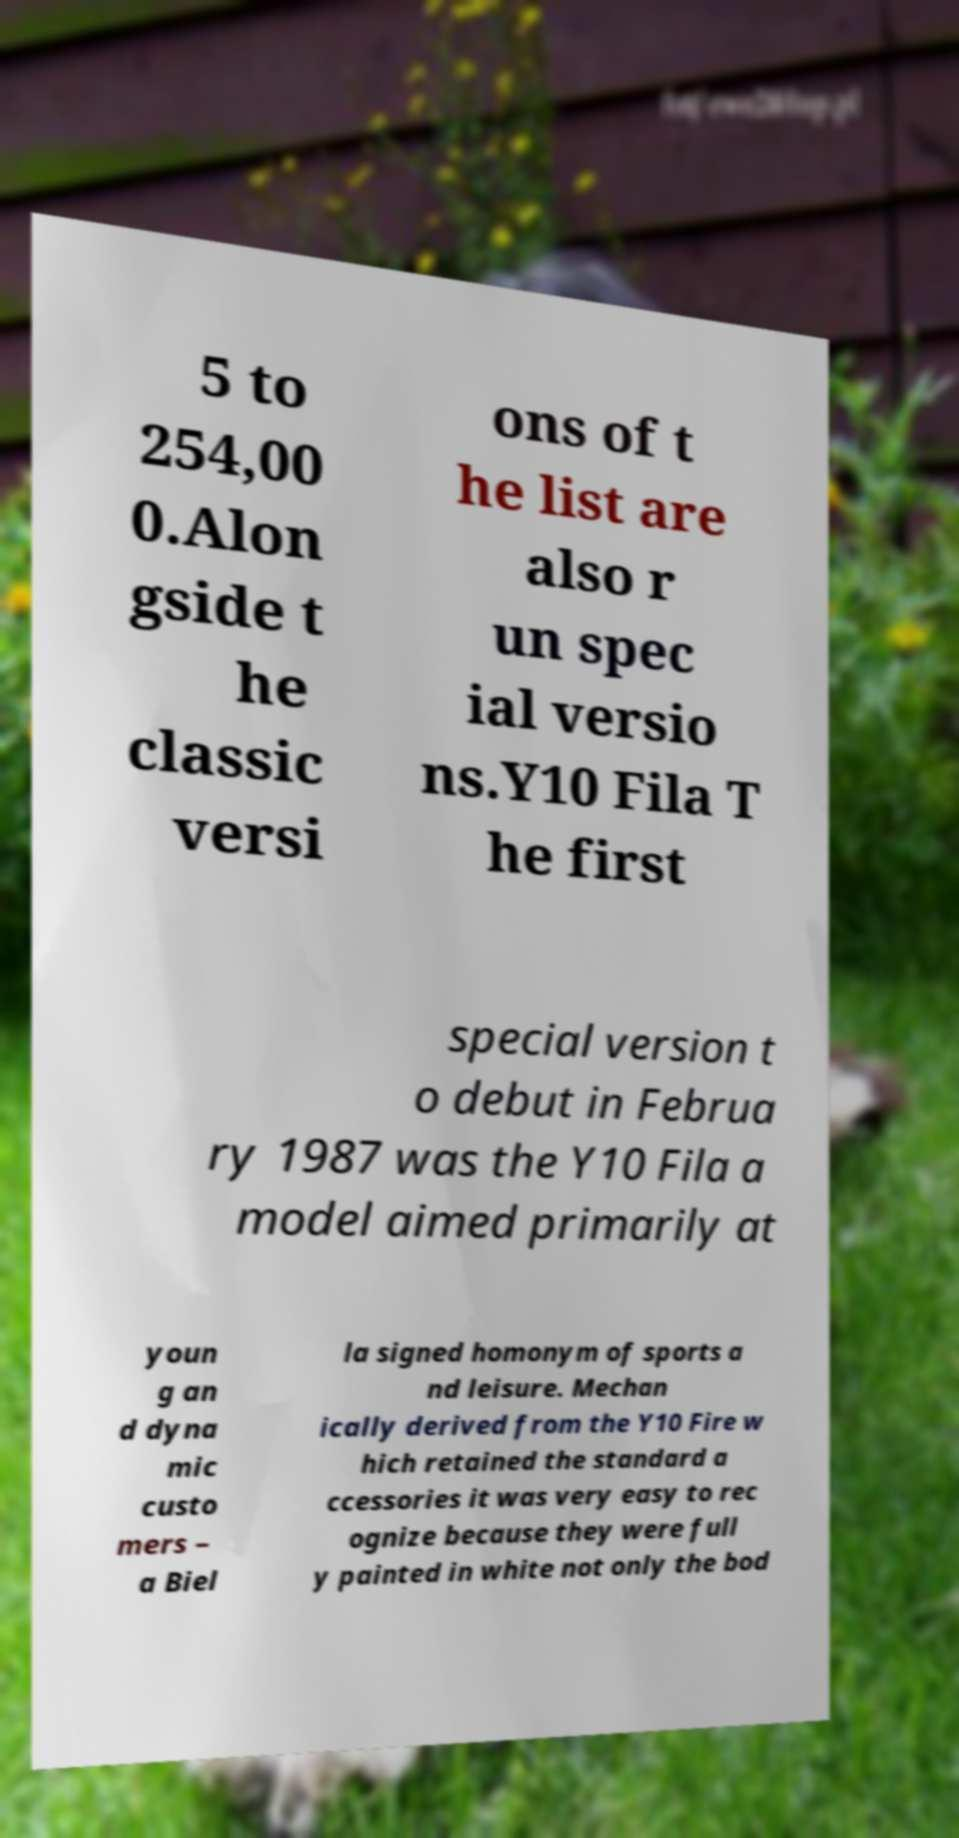Can you read and provide the text displayed in the image?This photo seems to have some interesting text. Can you extract and type it out for me? 5 to 254,00 0.Alon gside t he classic versi ons of t he list are also r un spec ial versio ns.Y10 Fila T he first special version t o debut in Februa ry 1987 was the Y10 Fila a model aimed primarily at youn g an d dyna mic custo mers – a Biel la signed homonym of sports a nd leisure. Mechan ically derived from the Y10 Fire w hich retained the standard a ccessories it was very easy to rec ognize because they were full y painted in white not only the bod 